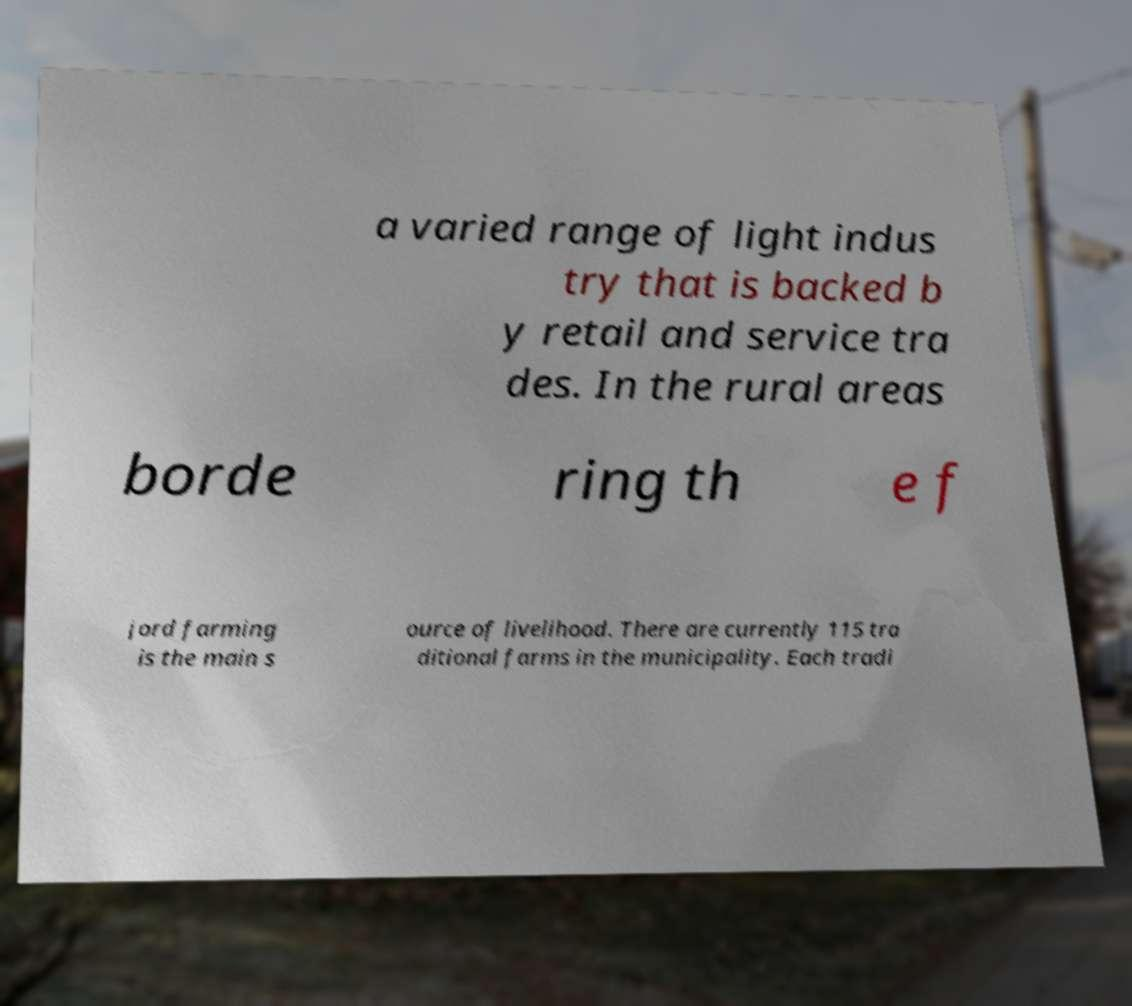What messages or text are displayed in this image? I need them in a readable, typed format. a varied range of light indus try that is backed b y retail and service tra des. In the rural areas borde ring th e f jord farming is the main s ource of livelihood. There are currently 115 tra ditional farms in the municipality. Each tradi 